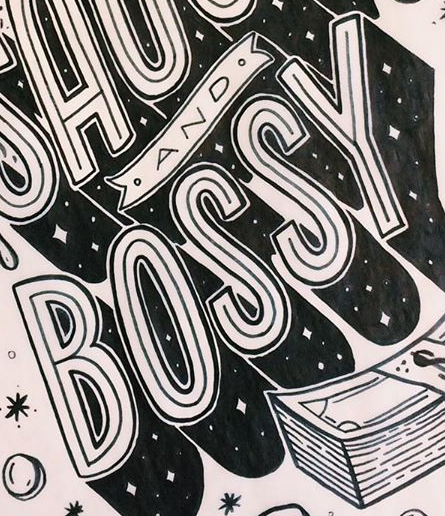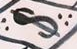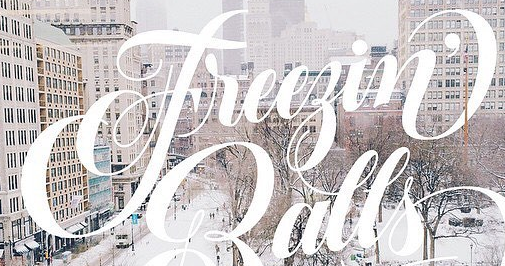What words are shown in these images in order, separated by a semicolon? BOSSY; $; Freegin' 